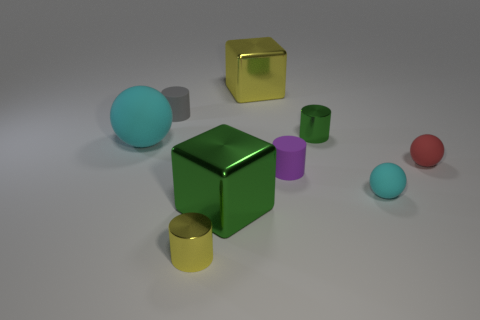Subtract all tiny cyan rubber balls. How many balls are left? 2 Subtract all green cylinders. How many cyan spheres are left? 2 Subtract all yellow cylinders. How many cylinders are left? 3 Subtract all cylinders. How many objects are left? 5 Add 1 tiny matte things. How many objects exist? 10 Subtract 0 gray spheres. How many objects are left? 9 Subtract all cyan spheres. Subtract all yellow blocks. How many spheres are left? 1 Subtract all green objects. Subtract all small purple things. How many objects are left? 6 Add 8 small red matte objects. How many small red matte objects are left? 9 Add 3 tiny objects. How many tiny objects exist? 9 